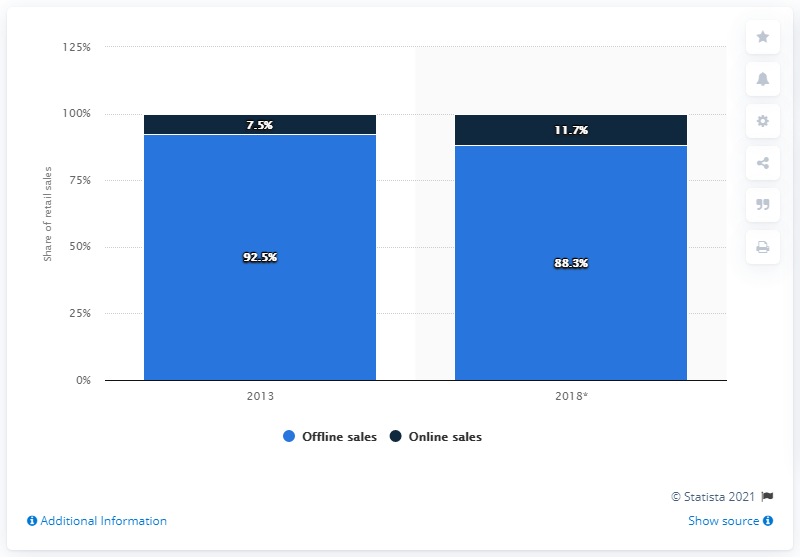Mention a couple of crucial points in this snapshot. The average of online sales is 9.6. In 2013, online sales accounted for 7.5 percent of sales of books, news, and stationery. By 2018, it is predicted that online sales of books, news, and stationery will increase by 11.7%. Blue bars in the chart represent offline sales. 